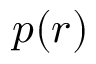<formula> <loc_0><loc_0><loc_500><loc_500>p ( r )</formula> 